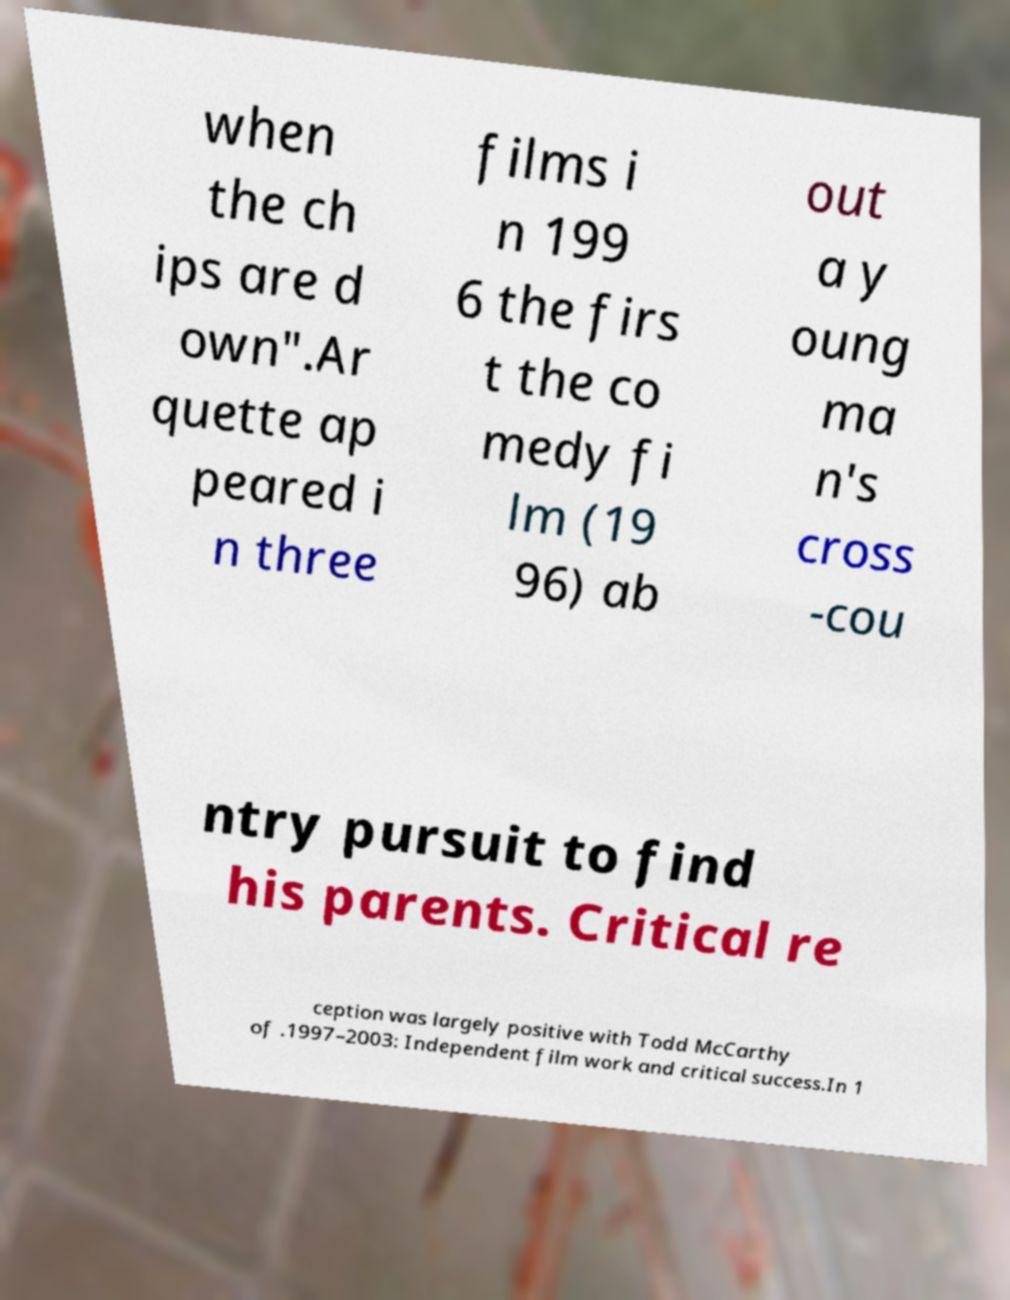Could you assist in decoding the text presented in this image and type it out clearly? when the ch ips are d own".Ar quette ap peared i n three films i n 199 6 the firs t the co medy fi lm (19 96) ab out a y oung ma n's cross -cou ntry pursuit to find his parents. Critical re ception was largely positive with Todd McCarthy of .1997–2003: Independent film work and critical success.In 1 